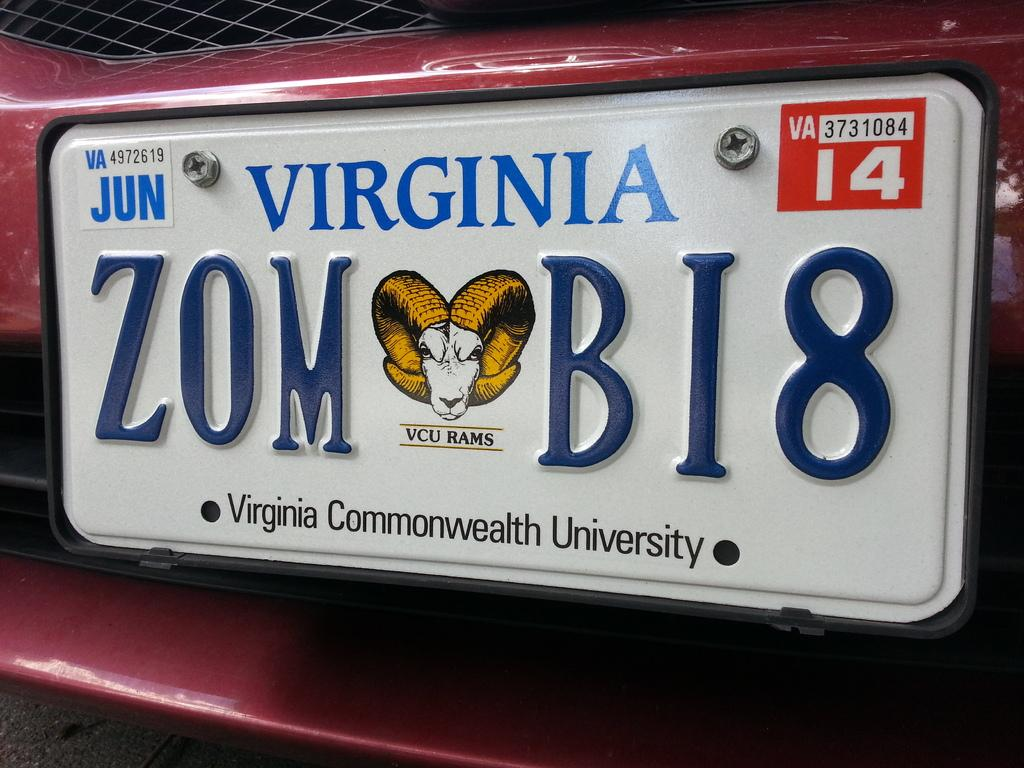<image>
Write a terse but informative summary of the picture. A license plate that says Virginia in blue letters above the license number, 